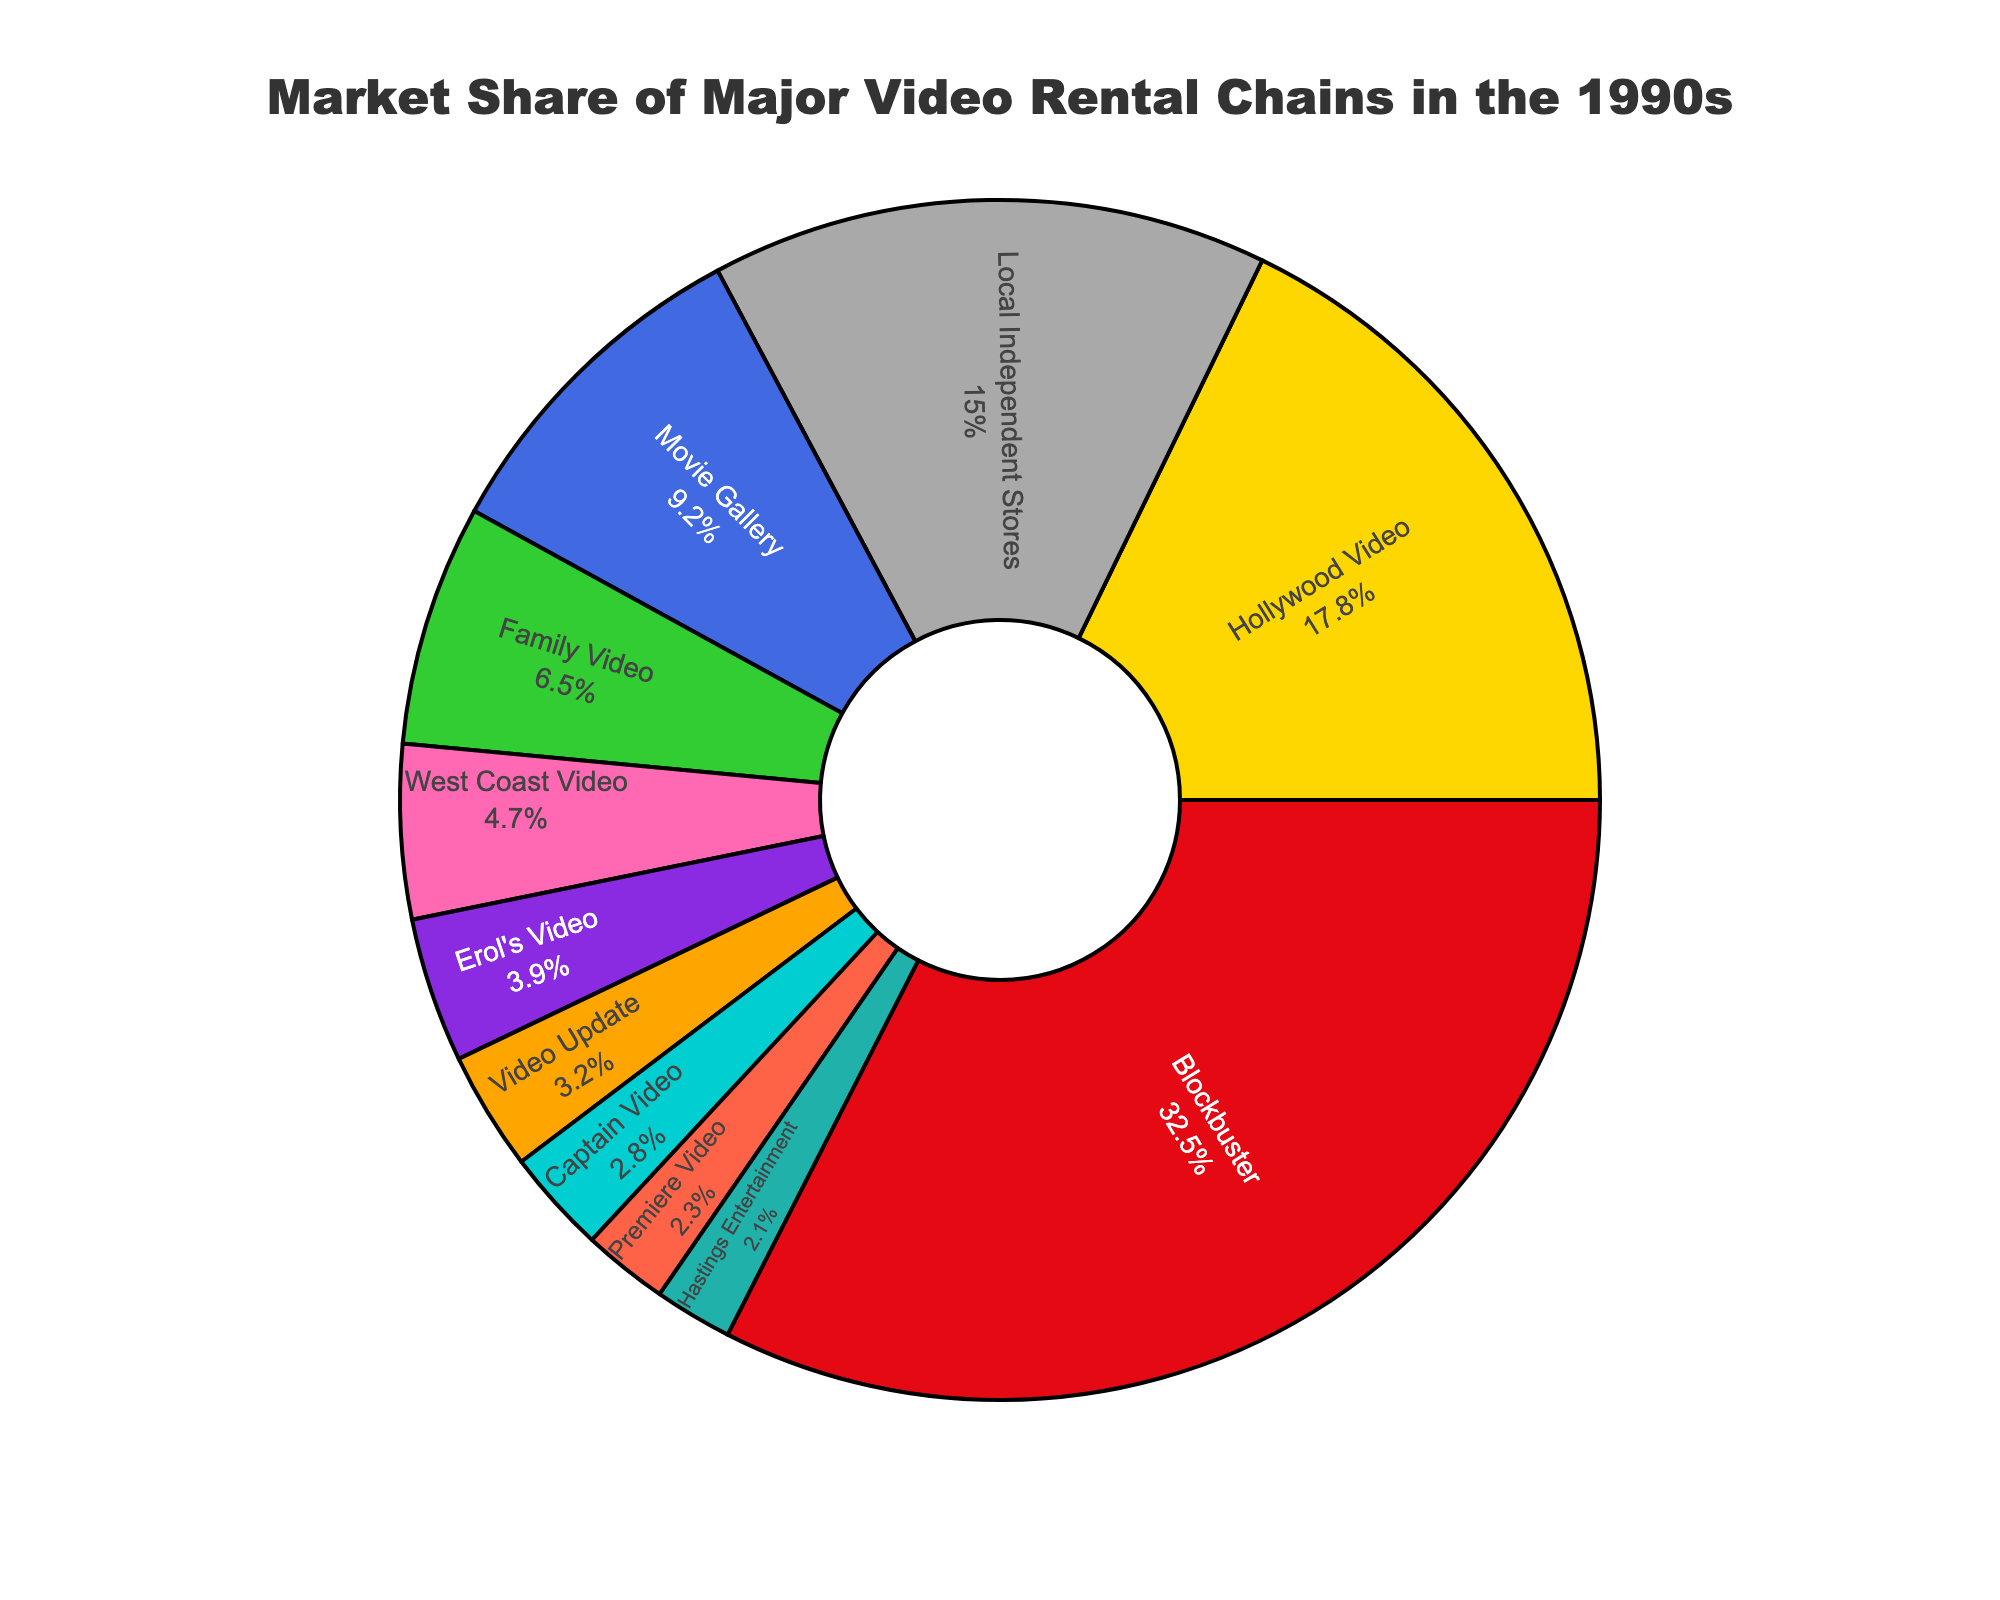What is the market share of Blockbuster in the pie chart? Look for the label "Blockbuster" in the pie chart and note the percentage value next to it. Blockbuster has a market share of 32.5%.
Answer: 32.5% Which company has the second-largest market share after Blockbuster? Identify the company with the largest market share, which is Blockbuster with 32.5%. Next, look for the company with the next highest percentage on the chart, which is Hollywood Video with 17.8%.
Answer: Hollywood Video What is the combined market share of Movie Gallery and Family Video? Locate Movie Gallery and Family Video on the pie chart. Movie Gallery has a market share of 9.2% and Family Video has 6.5%. Adding these two values gives 9.2% + 6.5% = 15.7%.
Answer: 15.7% How does the market share of Local Independent Stores compare to that of Hollywood Video? Find the market share percentages for Hollywood Video (17.8%) and Local Independent Stores (15.0%) on the pie chart. Hollywood Video's market share is larger than that of Local Independent Stores by 17.8% - 15.0% = 2.8%.
Answer: Hollywood Video has a 2.8% greater market share Which company has the smallest market share, and what is the value? Identify the company with the smallest segment in the pie chart. Hastings Entertainment has the smallest market share, which is 2.1%.
Answer: Hastings Entertainment, 2.1% What is the market share range of all companies? The range is calculated by finding the difference between the largest market share and the smallest market share on the chart. The largest is Blockbuster with 32.5% and the smallest is Hastings Entertainment with 2.1%. The range is 32.5% - 2.1% = 30.4%.
Answer: 30.4% What fraction of the market is controlled by the top three companies (Blockbuster, Hollywood Video, and Movie Gallery)? Sum the market shares of the top three companies. Blockbuster has 32.5%, Hollywood Video has 17.8%, and Movie Gallery has 9.2%. Adding these values gives 32.5% + 17.8% + 9.2% = 59.5%.
Answer: 59.5% Determine the difference in market share between Captain Video and Video Update. Find the market shares for Captain Video and Video Update. Captain Video has 2.8% and Video Update has 3.2%. The difference is 3.2% - 2.8% = 0.4%.
Answer: 0.4% How much larger is Blockbuster's market share compared to the combined market share of West Coast Video and Erol's Video? Compare Blockbuster's market share (32.5%) to the sum of West Coast Video (4.7%) and Erol’s Video (3.9%). First sum West Coast Video and Erol's Video: 4.7% + 3.9% = 8.6%. Then, subtract this sum from Blockbuster's share: 32.5% - 8.6% = 23.9%.
Answer: 23.9% 